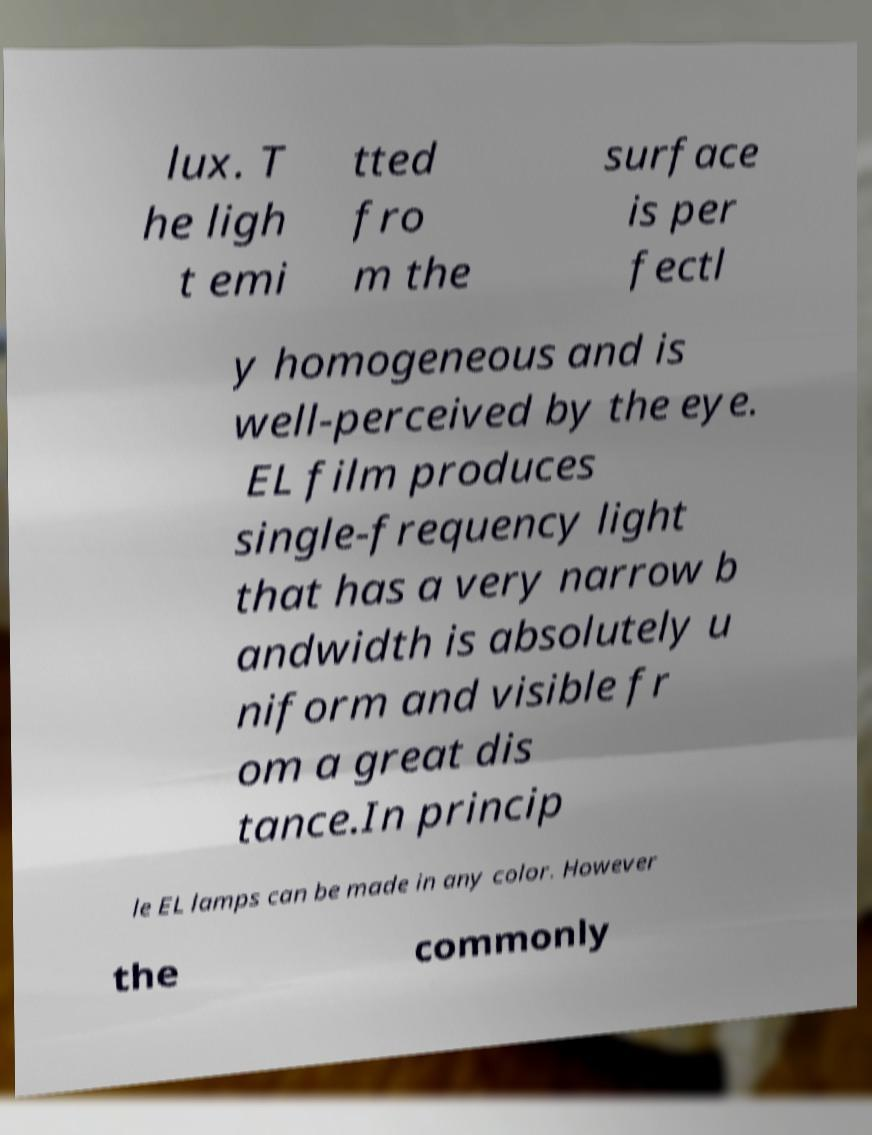What messages or text are displayed in this image? I need them in a readable, typed format. lux. T he ligh t emi tted fro m the surface is per fectl y homogeneous and is well-perceived by the eye. EL film produces single-frequency light that has a very narrow b andwidth is absolutely u niform and visible fr om a great dis tance.In princip le EL lamps can be made in any color. However the commonly 